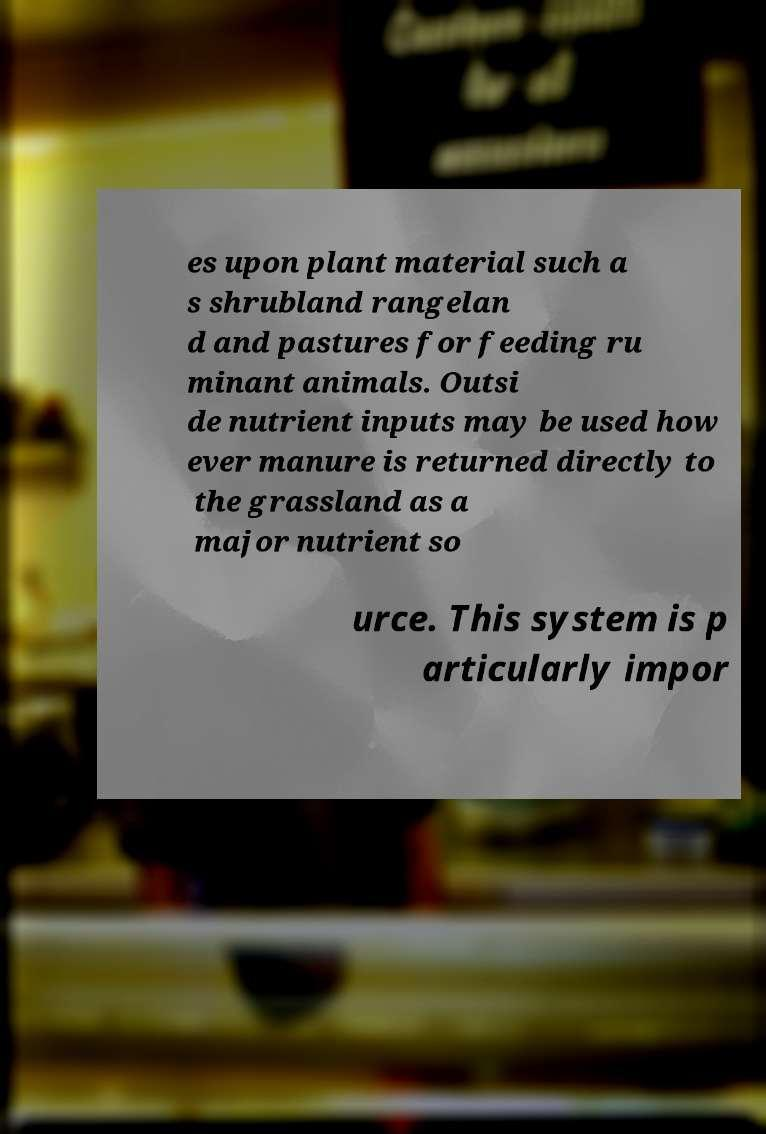What messages or text are displayed in this image? I need them in a readable, typed format. es upon plant material such a s shrubland rangelan d and pastures for feeding ru minant animals. Outsi de nutrient inputs may be used how ever manure is returned directly to the grassland as a major nutrient so urce. This system is p articularly impor 